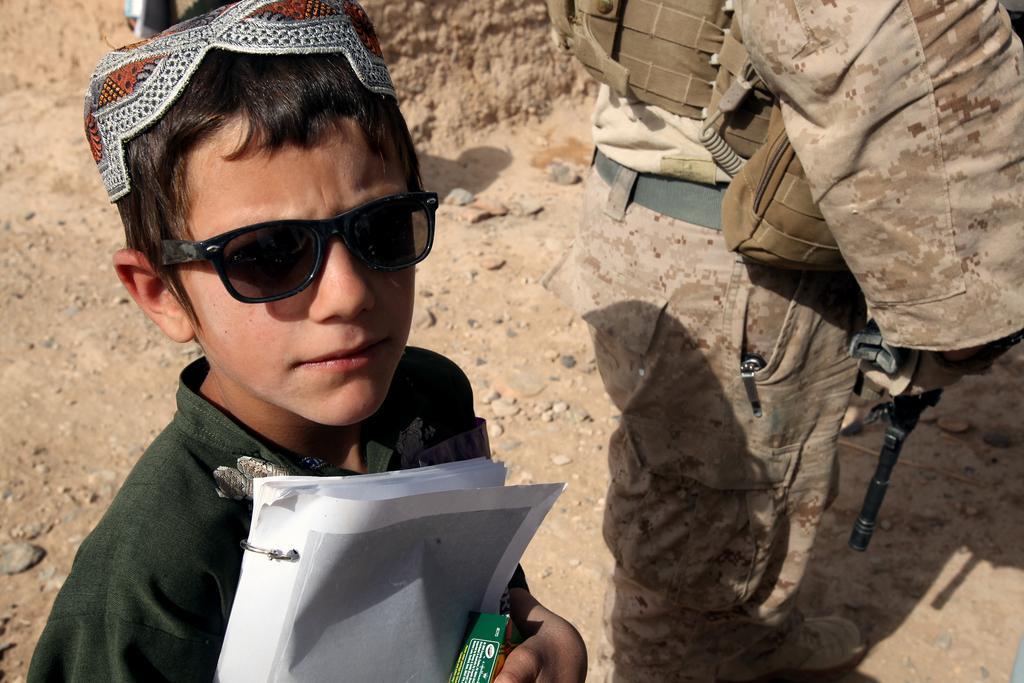How would you summarize this image in a sentence or two? In this image we can see persons standing on the ground and one of them is holding papers in the hands. 